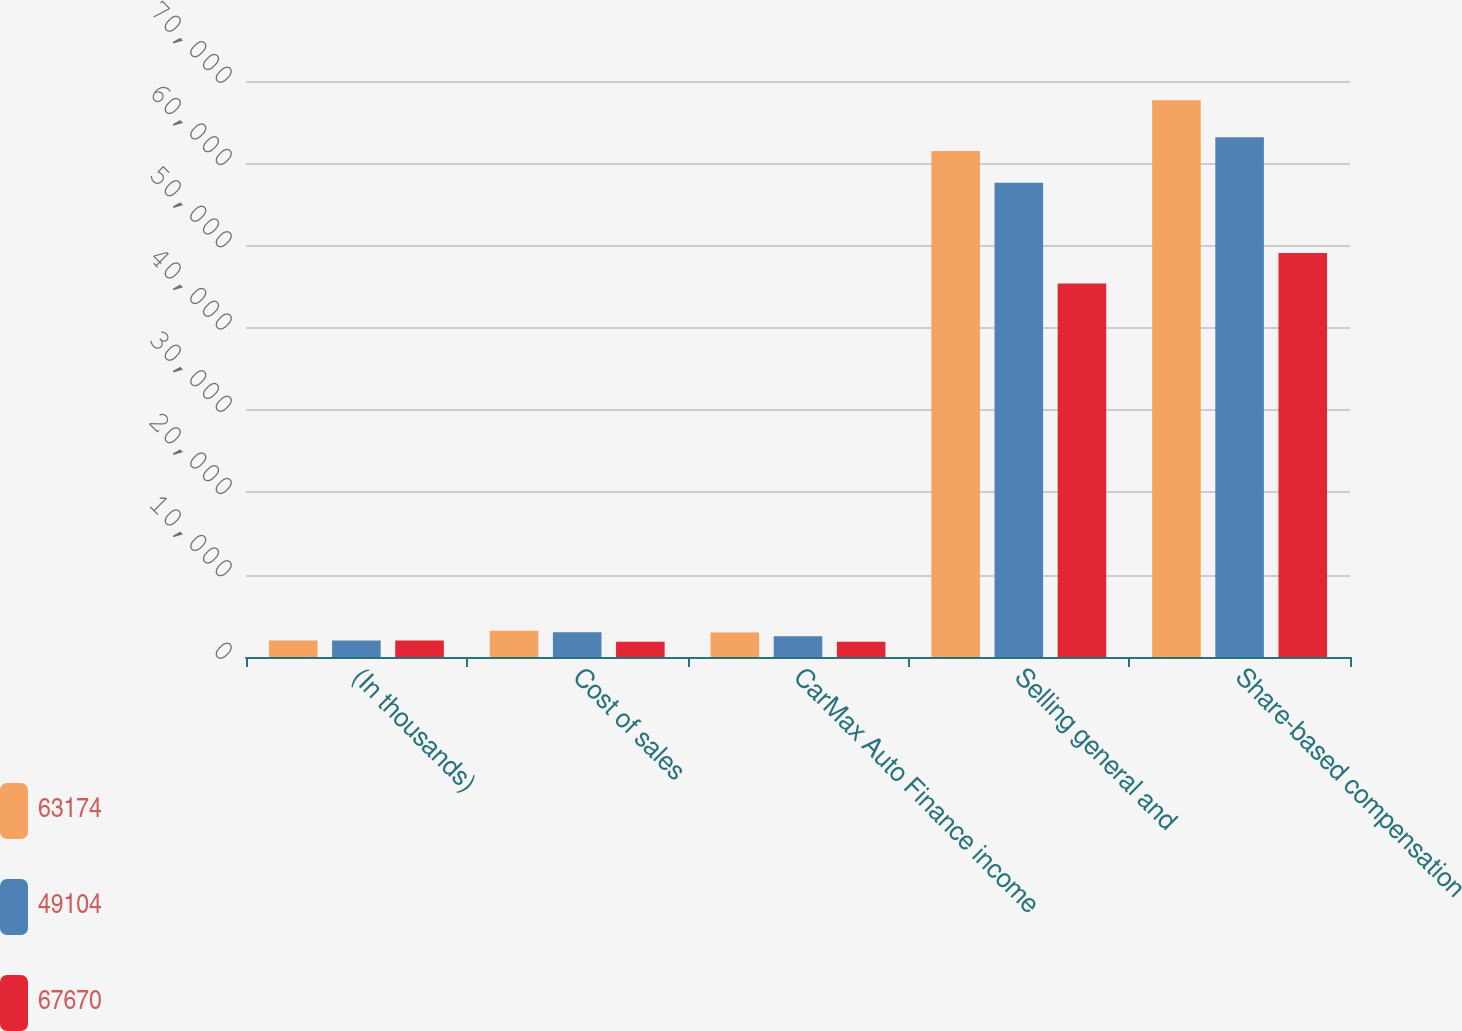<chart> <loc_0><loc_0><loc_500><loc_500><stacked_bar_chart><ecel><fcel>(In thousands)<fcel>Cost of sales<fcel>CarMax Auto Finance income<fcel>Selling general and<fcel>Share-based compensation<nl><fcel>63174<fcel>2014<fcel>3200<fcel>2983<fcel>61487<fcel>67670<nl><fcel>49104<fcel>2013<fcel>3010<fcel>2521<fcel>57643<fcel>63174<nl><fcel>67670<fcel>2012<fcel>1845<fcel>1867<fcel>45392<fcel>49104<nl></chart> 